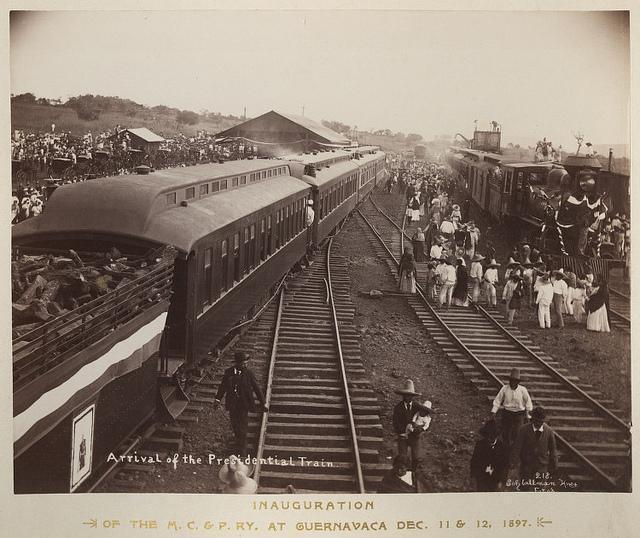How many trains are there?
Give a very brief answer. 2. How many trains are in the picture?
Give a very brief answer. 2. How many people are there?
Give a very brief answer. 4. 